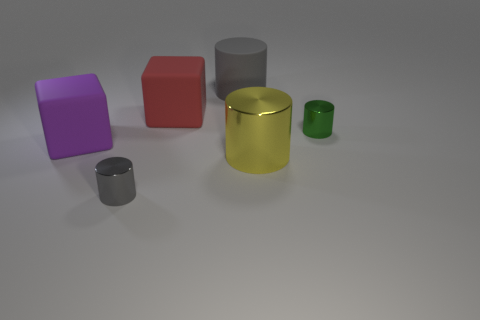The big shiny cylinder has what color?
Offer a terse response. Yellow. What shape is the tiny object behind the tiny thing that is in front of the small metallic thing behind the big yellow metallic cylinder?
Offer a very short reply. Cylinder. What is the object that is behind the tiny gray metallic cylinder and left of the large red cube made of?
Your response must be concise. Rubber. The small metallic object right of the block right of the purple cube is what shape?
Keep it short and to the point. Cylinder. Are there any other things that have the same color as the large shiny cylinder?
Your answer should be very brief. No. There is a matte cylinder; is its size the same as the red thing that is in front of the big gray cylinder?
Offer a terse response. Yes. How many large things are gray shiny cylinders or brown cylinders?
Provide a succinct answer. 0. Is the number of large cylinders greater than the number of small gray cubes?
Keep it short and to the point. Yes. There is a large rubber block in front of the metal object right of the large yellow object; what number of green shiny cylinders are in front of it?
Make the answer very short. 0. What is the shape of the big gray rubber object?
Your answer should be compact. Cylinder. 